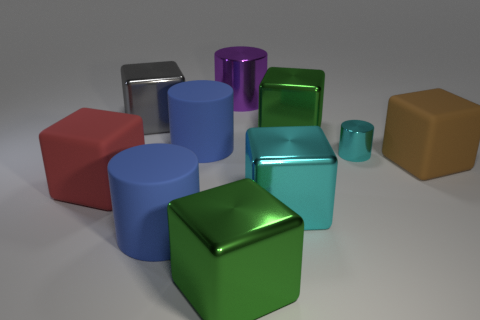There is a red thing that is the same shape as the large brown rubber thing; what is its size?
Offer a terse response. Large. There is a large rubber object behind the rubber thing that is on the right side of the big purple cylinder that is behind the big brown matte thing; what color is it?
Your answer should be very brief. Blue. Do the big metallic thing behind the large gray thing and the thing to the left of the gray metallic cube have the same shape?
Provide a short and direct response. No. What number of cyan blocks are there?
Keep it short and to the point. 1. There is another matte block that is the same size as the red rubber block; what is its color?
Give a very brief answer. Brown. Are the blue cylinder that is behind the small cyan object and the big cylinder that is in front of the cyan cylinder made of the same material?
Offer a very short reply. Yes. There is a metal cylinder that is right of the green metal block that is behind the cyan cylinder; what is its size?
Keep it short and to the point. Small. What is the material of the big blue object that is in front of the brown thing?
Offer a very short reply. Rubber. What number of objects are shiny things that are on the right side of the purple cylinder or objects in front of the large gray shiny block?
Keep it short and to the point. 8. What material is the other purple thing that is the same shape as the tiny shiny thing?
Ensure brevity in your answer.  Metal. 